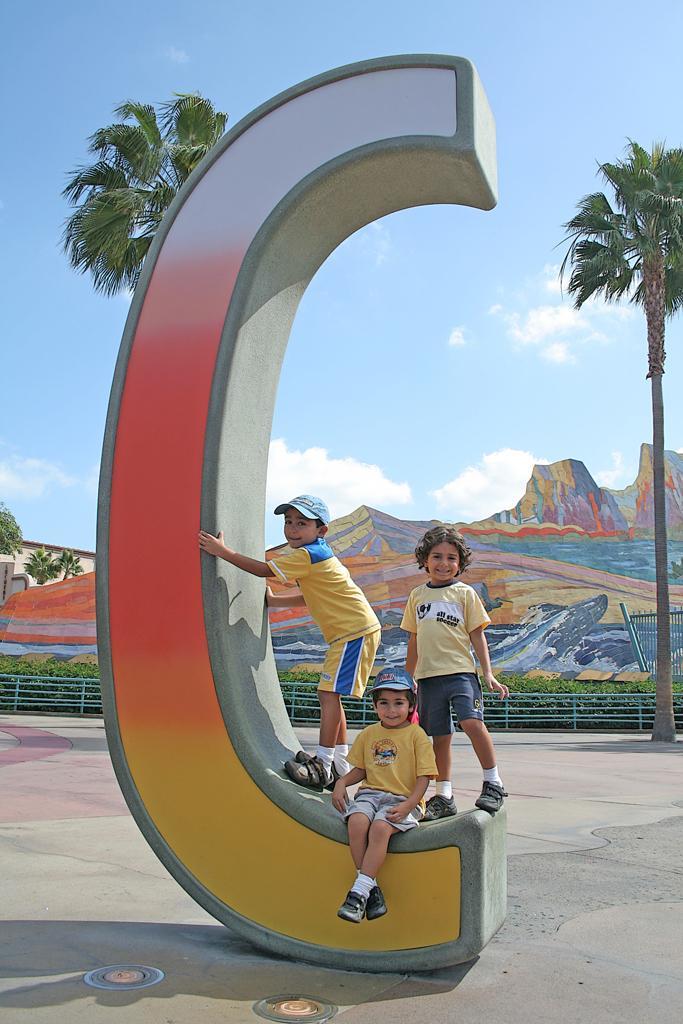Could you give a brief overview of what you see in this image? In the image few people are standing and sitting and there is a wall. Behind the wall there is fencing and plants and trees and hills and clouds and sky. 